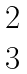Convert formula to latex. <formula><loc_0><loc_0><loc_500><loc_500>\begin{matrix} 2 \\ 3 \end{matrix}</formula> 